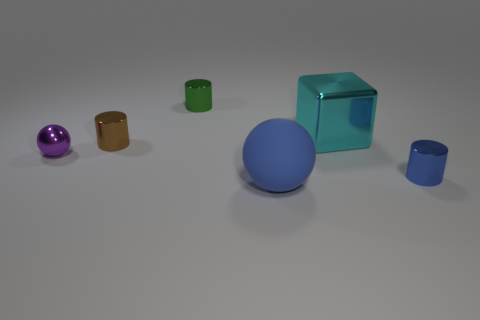Add 1 green cylinders. How many objects exist? 7 Subtract all balls. How many objects are left? 4 Add 3 small brown metal cylinders. How many small brown metal cylinders exist? 4 Subtract 0 brown spheres. How many objects are left? 6 Subtract all brown objects. Subtract all small purple objects. How many objects are left? 4 Add 5 cubes. How many cubes are left? 6 